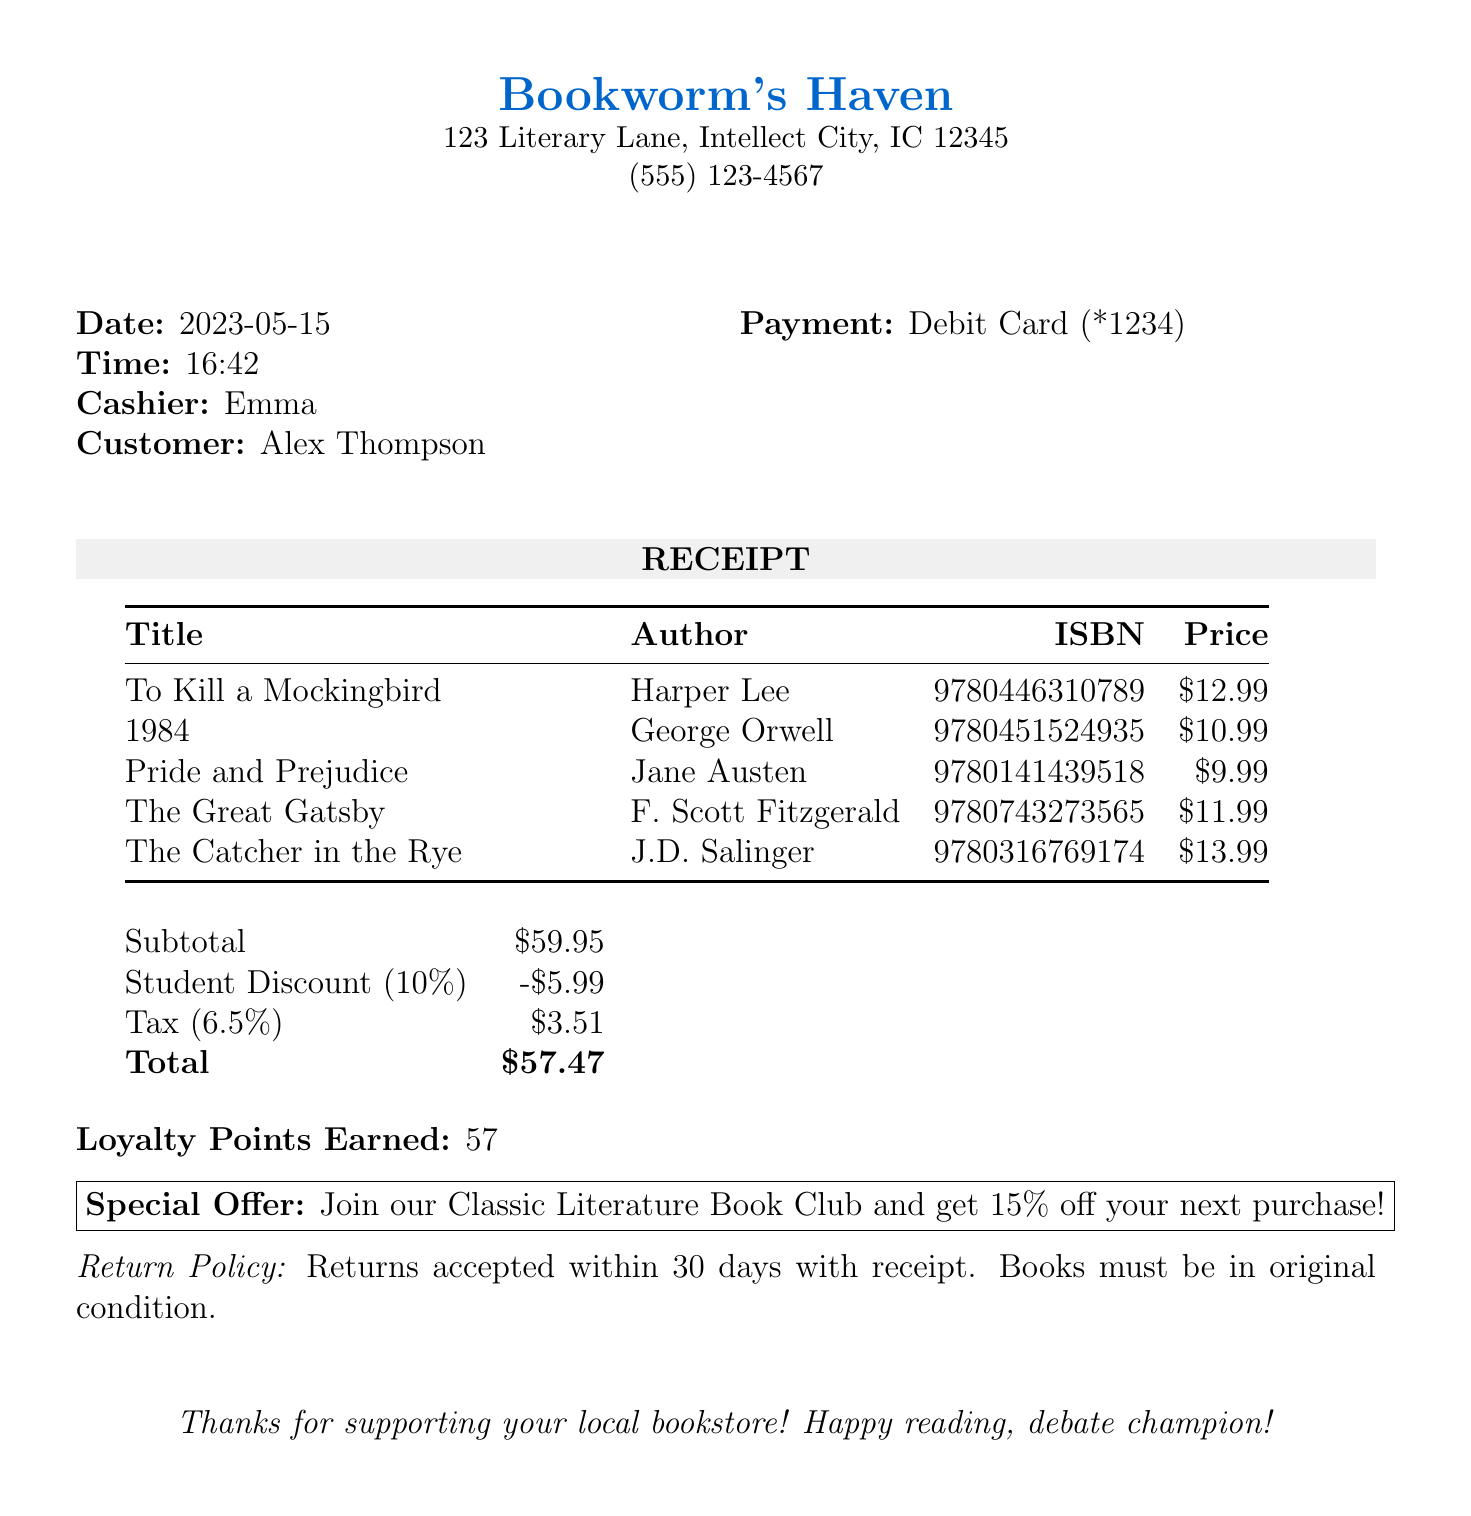What is the store name? The store name is listed at the top of the receipt.
Answer: Bookworm's Haven What is the customer’s name? The customer’s name is provided in the receipt details section.
Answer: Alex Thompson What is the total amount after discounts and tax? The total amount is calculated at the bottom of the receipt, factoring in discounts and tax.
Answer: 57.47 What is the date of the purchase? The purchase date is mentioned in the receipt details.
Answer: 2023-05-15 How much was the student discount? The student discount amount is specified in the discount section of the receipt.
Answer: 5.99 What is the phone number of the bookstore? The bookstore's phone number is listed beneath the store name.
Answer: (555) 123-4567 How many loyalty points were earned? The loyalty points earned are indicated at the bottom of the receipt.
Answer: 57 What is the return policy duration? The return policy section mentions how long returns are accepted.
Answer: 30 days What special offer is provided? The special offer is clearly outlined in a box towards the bottom of the receipt.
Answer: Join our Classic Literature Book Club and get 15% off your next purchase! 